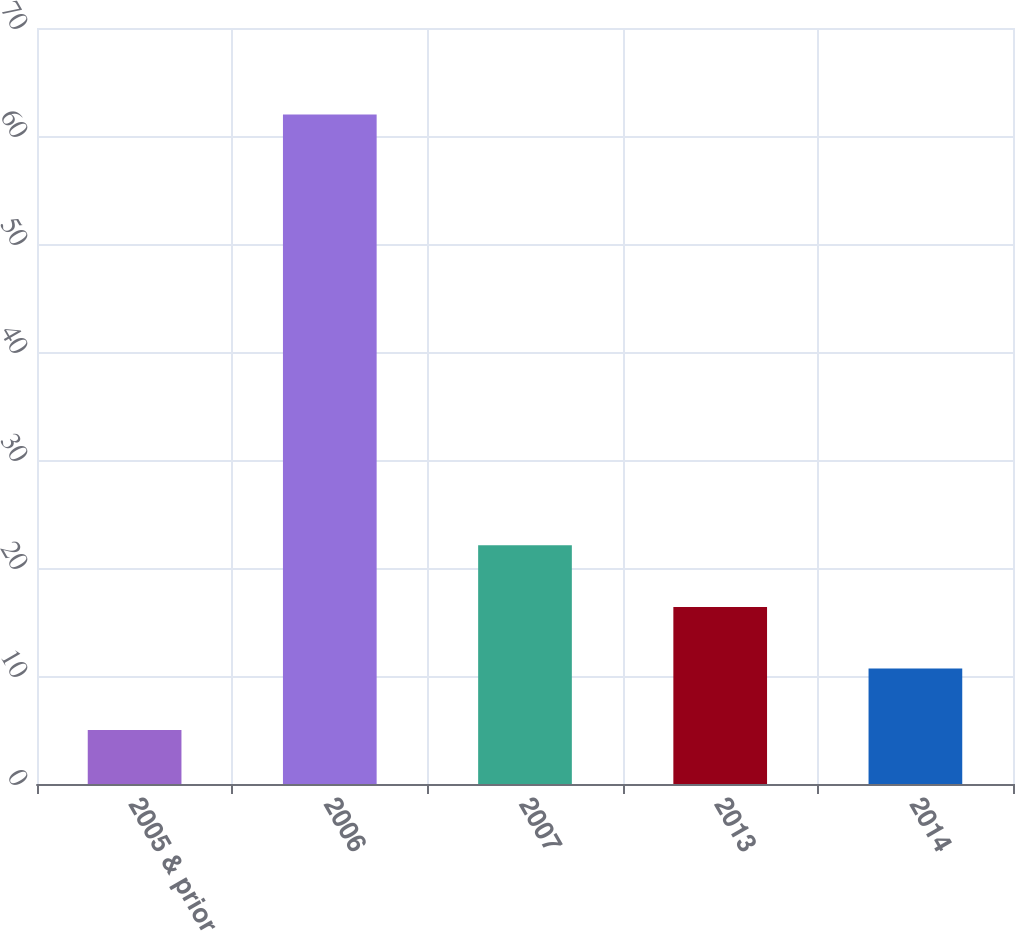Convert chart to OTSL. <chart><loc_0><loc_0><loc_500><loc_500><bar_chart><fcel>2005 & prior<fcel>2006<fcel>2007<fcel>2013<fcel>2014<nl><fcel>5<fcel>62<fcel>22.1<fcel>16.4<fcel>10.7<nl></chart> 